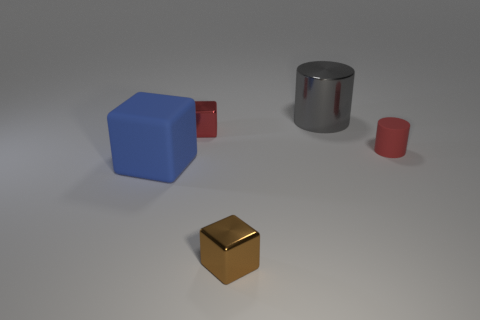Add 5 green metal blocks. How many objects exist? 10 Subtract all metal cubes. How many cubes are left? 1 Subtract all green spheres. How many blue blocks are left? 1 Subtract all cyan metallic objects. Subtract all small red rubber cylinders. How many objects are left? 4 Add 5 small brown blocks. How many small brown blocks are left? 6 Add 1 tiny green blocks. How many tiny green blocks exist? 1 Subtract all red cylinders. How many cylinders are left? 1 Subtract 1 blue blocks. How many objects are left? 4 Subtract all cylinders. How many objects are left? 3 Subtract 3 cubes. How many cubes are left? 0 